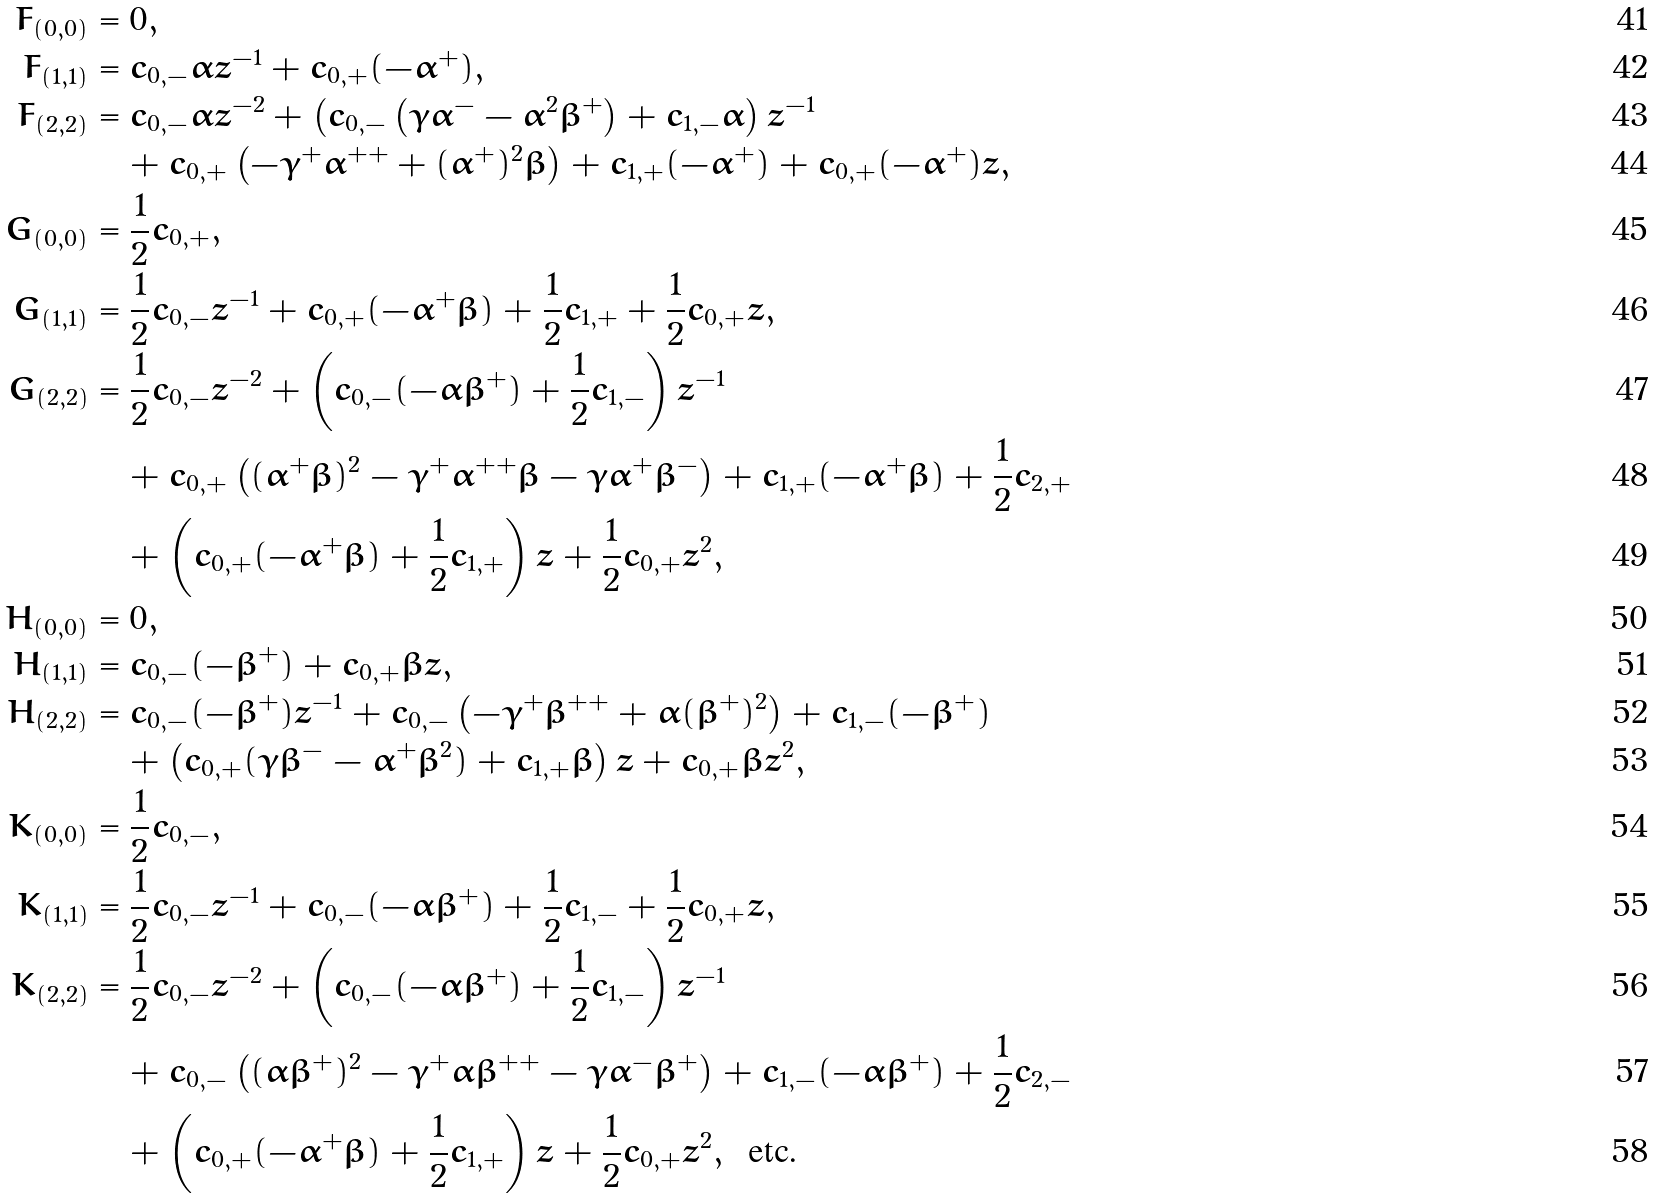<formula> <loc_0><loc_0><loc_500><loc_500>F _ { ( 0 , 0 ) } & = 0 , \\ F _ { ( 1 , 1 ) } & = c _ { 0 , - } \alpha z ^ { - 1 } + c _ { 0 , + } ( - \alpha ^ { + } ) , \\ F _ { ( 2 , 2 ) } & = c _ { 0 , - } \alpha z ^ { - 2 } + \left ( c _ { 0 , - } \left ( \gamma \alpha ^ { - } - \alpha ^ { 2 } \beta ^ { + } \right ) + c _ { 1 , - } \alpha \right ) z ^ { - 1 } \\ & \quad + c _ { 0 , + } \left ( - \gamma ^ { + } \alpha ^ { + + } + ( \alpha ^ { + } ) ^ { 2 } \beta \right ) + c _ { 1 , + } ( - \alpha ^ { + } ) + c _ { 0 , + } ( - \alpha ^ { + } ) z , \\ G _ { ( 0 , 0 ) } & = \frac { 1 } { 2 } c _ { 0 , + } , \\ G _ { ( 1 , 1 ) } & = \frac { 1 } { 2 } c _ { 0 , - } z ^ { - 1 } + c _ { 0 , + } ( - \alpha ^ { + } \beta ) + \frac { 1 } { 2 } c _ { 1 , + } + \frac { 1 } { 2 } c _ { 0 , + } z , \\ G _ { ( 2 , 2 ) } & = \frac { 1 } { 2 } c _ { 0 , - } z ^ { - 2 } + \left ( c _ { 0 , - } ( - \alpha \beta ^ { + } ) + \frac { 1 } { 2 } c _ { 1 , - } \right ) z ^ { - 1 } \\ & \quad + c _ { 0 , + } \left ( ( \alpha ^ { + } \beta ) ^ { 2 } - \gamma ^ { + } \alpha ^ { + + } \beta - \gamma \alpha ^ { + } \beta ^ { - } \right ) + c _ { 1 , + } ( - \alpha ^ { + } \beta ) + \frac { 1 } { 2 } c _ { 2 , + } \\ & \quad + \left ( c _ { 0 , + } ( - \alpha ^ { + } \beta ) + \frac { 1 } { 2 } c _ { 1 , + } \right ) z + \frac { 1 } { 2 } c _ { 0 , + } z ^ { 2 } , \\ H _ { ( 0 , 0 ) } & = 0 , \\ H _ { ( 1 , 1 ) } & = c _ { 0 , - } ( - \beta ^ { + } ) + c _ { 0 , + } \beta z , \\ H _ { ( 2 , 2 ) } & = c _ { 0 , - } ( - \beta ^ { + } ) z ^ { - 1 } + c _ { 0 , - } \left ( - \gamma ^ { + } \beta ^ { + + } + \alpha ( \beta ^ { + } ) ^ { 2 } \right ) + c _ { 1 , - } ( - \beta ^ { + } ) \\ & \quad + \left ( c _ { 0 , + } ( \gamma \beta ^ { - } - \alpha ^ { + } \beta ^ { 2 } ) + c _ { 1 , + } \beta \right ) z + c _ { 0 , + } \beta z ^ { 2 } , \\ K _ { ( 0 , 0 ) } & = \frac { 1 } { 2 } c _ { 0 , - } , \\ K _ { ( 1 , 1 ) } & = \frac { 1 } { 2 } c _ { 0 , - } z ^ { - 1 } + c _ { 0 , - } ( - \alpha \beta ^ { + } ) + \frac { 1 } { 2 } c _ { 1 , - } + \frac { 1 } { 2 } c _ { 0 , + } z , \\ K _ { ( 2 , 2 ) } & = \frac { 1 } { 2 } c _ { 0 , - } z ^ { - 2 } + \left ( c _ { 0 , - } ( - \alpha \beta ^ { + } ) + \frac { 1 } { 2 } c _ { 1 , - } \right ) z ^ { - 1 } \\ & \quad + c _ { 0 , - } \left ( ( \alpha \beta ^ { + } ) ^ { 2 } - \gamma ^ { + } \alpha \beta ^ { + + } - \gamma \alpha ^ { - } \beta ^ { + } \right ) + c _ { 1 , - } ( - \alpha \beta ^ { + } ) + \frac { 1 } { 2 } c _ { 2 , - } \\ & \quad + \left ( c _ { 0 , + } ( - \alpha ^ { + } \beta ) + \frac { 1 } { 2 } c _ { 1 , + } \right ) z + \frac { 1 } { 2 } c _ { 0 , + } z ^ { 2 } , \, \text { etc.}</formula> 